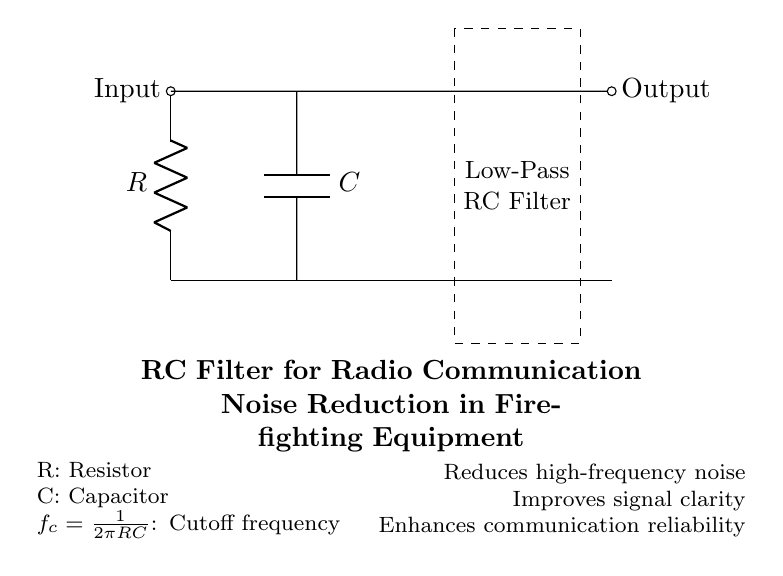What type of filter is represented in the circuit? The diagram shows a low-pass RC filter, which is emphasized inside the dashed rectangle. A low-pass filter allows low-frequency signals to pass while attenuating higher frequency signals.
Answer: low-pass RC filter What are the components used in this circuit? The circuit consists of a Resistor (R) and a Capacitor (C), as labeled on the diagram. These are the primary components that define an RC circuit.
Answer: Resistor and Capacitor What is the function of the capacitor in this circuit? The capacitor's role in an RC filter is to store and release energy, which helps to smooth out the voltage and filter high-frequency noise signals. This functionality is essential for noise reduction in communication systems.
Answer: Noise reduction What does the symbol "f_c" represent? The symbol "f_c" refers to the cutoff frequency, which is the frequency point at which the output signal is reduced to a specific fraction (about 70.7%) of the input signal. The formula presented shows how it is calculated based on the resistor and capacitor values.
Answer: Cutoff frequency How does the RC filter improve communication reliability? The RC filter enhances communication reliability by reducing high-frequency noise, which can interfere with the clarity of the signal transmitted in firefighting equipment. By smoothing the signal, it ensures better performance in critical communication situations.
Answer: Reduces interference What is the cut-off frequency formula given in the diagram? The formula provided in the diagram is f_c = 1 divided by 2 pi RC. This relationship shows how the cutoff frequency depends on the values of the resistor and capacitor in the circuit.
Answer: f_c = 1/(2πRC) What is the output node marked as in the circuit? The output node is marked as "Output" on the right side of the diagram. This area indicates where the filtered signal can be taken from, after being processed by the RC filter.
Answer: Output 